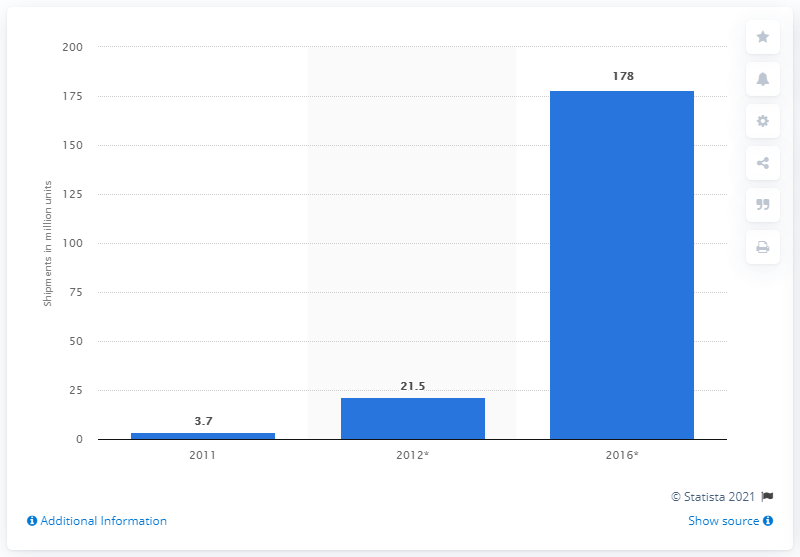Point out several critical features in this image. In 2011, a total of 3.7 million ultrabooks were shipped worldwide. 